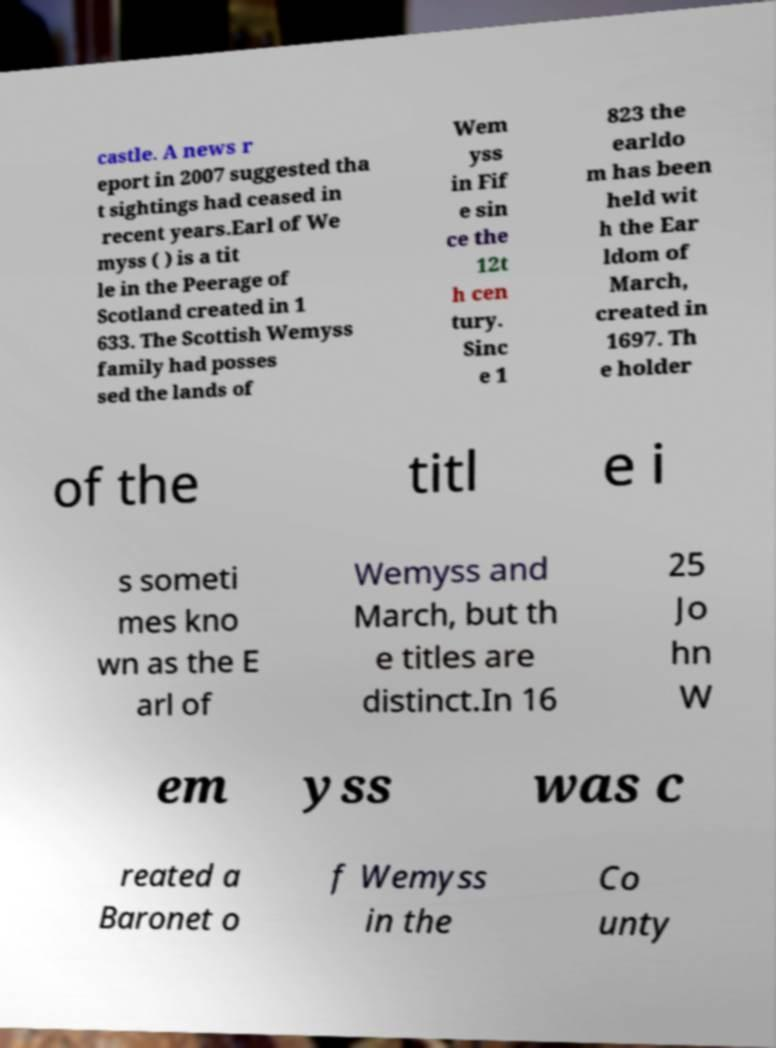For documentation purposes, I need the text within this image transcribed. Could you provide that? castle. A news r eport in 2007 suggested tha t sightings had ceased in recent years.Earl of We myss ( ) is a tit le in the Peerage of Scotland created in 1 633. The Scottish Wemyss family had posses sed the lands of Wem yss in Fif e sin ce the 12t h cen tury. Sinc e 1 823 the earldo m has been held wit h the Ear ldom of March, created in 1697. Th e holder of the titl e i s someti mes kno wn as the E arl of Wemyss and March, but th e titles are distinct.In 16 25 Jo hn W em yss was c reated a Baronet o f Wemyss in the Co unty 